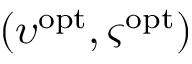<formula> <loc_0><loc_0><loc_500><loc_500>( \upsilon ^ { o p t } , \varsigma ^ { o p t } )</formula> 